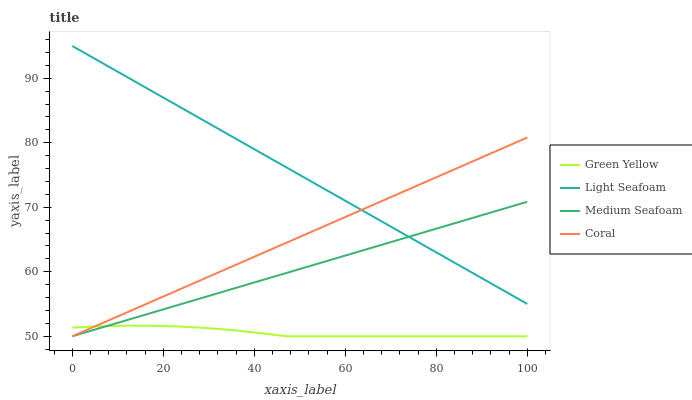Does Medium Seafoam have the minimum area under the curve?
Answer yes or no. No. Does Medium Seafoam have the maximum area under the curve?
Answer yes or no. No. Is Medium Seafoam the smoothest?
Answer yes or no. No. Is Medium Seafoam the roughest?
Answer yes or no. No. Does Light Seafoam have the lowest value?
Answer yes or no. No. Does Medium Seafoam have the highest value?
Answer yes or no. No. Is Green Yellow less than Light Seafoam?
Answer yes or no. Yes. Is Light Seafoam greater than Green Yellow?
Answer yes or no. Yes. Does Green Yellow intersect Light Seafoam?
Answer yes or no. No. 